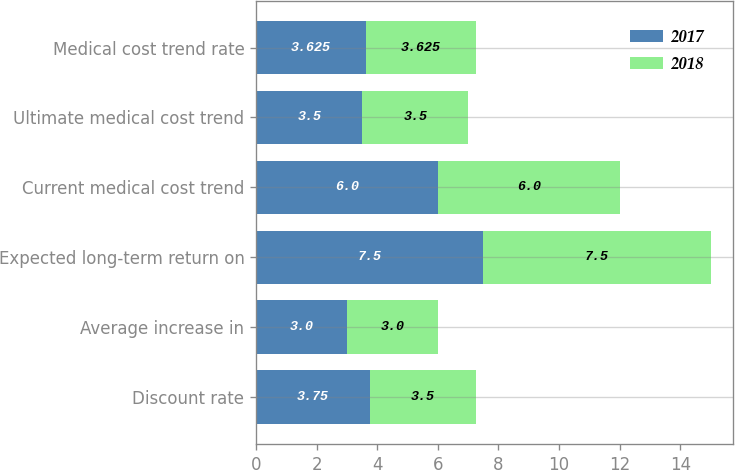Convert chart. <chart><loc_0><loc_0><loc_500><loc_500><stacked_bar_chart><ecel><fcel>Discount rate<fcel>Average increase in<fcel>Expected long-term return on<fcel>Current medical cost trend<fcel>Ultimate medical cost trend<fcel>Medical cost trend rate<nl><fcel>2017<fcel>3.75<fcel>3<fcel>7.5<fcel>6<fcel>3.5<fcel>3.625<nl><fcel>2018<fcel>3.5<fcel>3<fcel>7.5<fcel>6<fcel>3.5<fcel>3.625<nl></chart> 